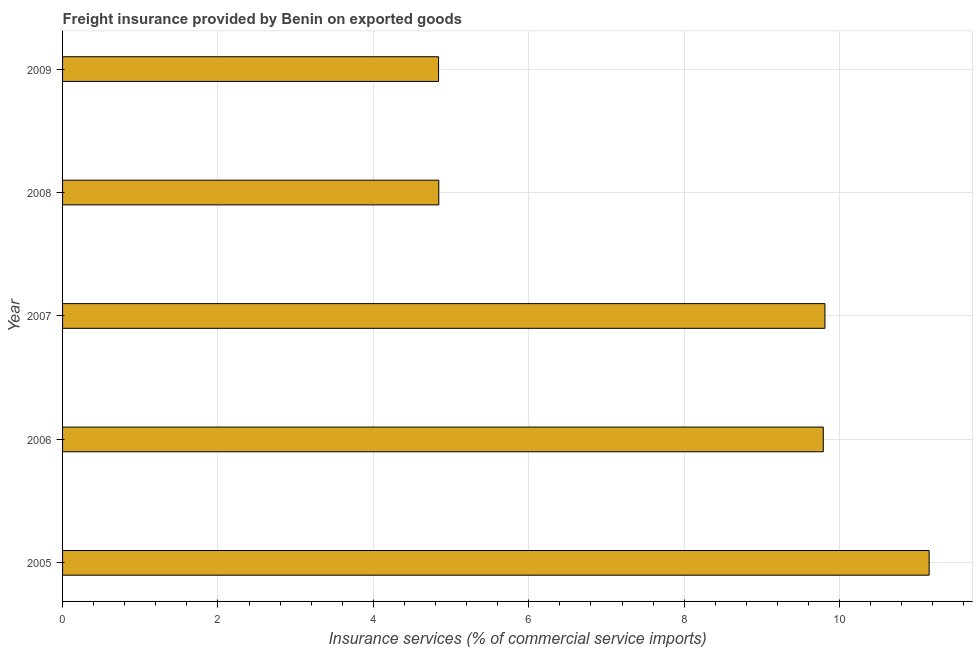Does the graph contain grids?
Your response must be concise. Yes. What is the title of the graph?
Give a very brief answer. Freight insurance provided by Benin on exported goods . What is the label or title of the X-axis?
Your response must be concise. Insurance services (% of commercial service imports). What is the freight insurance in 2009?
Ensure brevity in your answer.  4.84. Across all years, what is the maximum freight insurance?
Give a very brief answer. 11.15. Across all years, what is the minimum freight insurance?
Your answer should be compact. 4.84. In which year was the freight insurance maximum?
Ensure brevity in your answer.  2005. In which year was the freight insurance minimum?
Give a very brief answer. 2009. What is the sum of the freight insurance?
Offer a terse response. 40.43. What is the difference between the freight insurance in 2006 and 2009?
Offer a terse response. 4.95. What is the average freight insurance per year?
Your answer should be compact. 8.09. What is the median freight insurance?
Your answer should be very brief. 9.79. Do a majority of the years between 2009 and 2005 (inclusive) have freight insurance greater than 10.8 %?
Offer a very short reply. Yes. What is the ratio of the freight insurance in 2008 to that in 2009?
Your answer should be compact. 1. Is the freight insurance in 2007 less than that in 2009?
Provide a succinct answer. No. Is the difference between the freight insurance in 2006 and 2009 greater than the difference between any two years?
Ensure brevity in your answer.  No. What is the difference between the highest and the second highest freight insurance?
Your answer should be compact. 1.34. Is the sum of the freight insurance in 2008 and 2009 greater than the maximum freight insurance across all years?
Make the answer very short. No. What is the difference between the highest and the lowest freight insurance?
Your answer should be compact. 6.31. In how many years, is the freight insurance greater than the average freight insurance taken over all years?
Offer a terse response. 3. How many bars are there?
Make the answer very short. 5. How many years are there in the graph?
Give a very brief answer. 5. What is the difference between two consecutive major ticks on the X-axis?
Offer a very short reply. 2. Are the values on the major ticks of X-axis written in scientific E-notation?
Ensure brevity in your answer.  No. What is the Insurance services (% of commercial service imports) of 2005?
Provide a succinct answer. 11.15. What is the Insurance services (% of commercial service imports) of 2006?
Ensure brevity in your answer.  9.79. What is the Insurance services (% of commercial service imports) of 2007?
Offer a very short reply. 9.81. What is the Insurance services (% of commercial service imports) in 2008?
Provide a short and direct response. 4.84. What is the Insurance services (% of commercial service imports) of 2009?
Offer a terse response. 4.84. What is the difference between the Insurance services (% of commercial service imports) in 2005 and 2006?
Offer a terse response. 1.36. What is the difference between the Insurance services (% of commercial service imports) in 2005 and 2007?
Your response must be concise. 1.34. What is the difference between the Insurance services (% of commercial service imports) in 2005 and 2008?
Keep it short and to the point. 6.31. What is the difference between the Insurance services (% of commercial service imports) in 2005 and 2009?
Provide a short and direct response. 6.31. What is the difference between the Insurance services (% of commercial service imports) in 2006 and 2007?
Your response must be concise. -0.02. What is the difference between the Insurance services (% of commercial service imports) in 2006 and 2008?
Give a very brief answer. 4.95. What is the difference between the Insurance services (% of commercial service imports) in 2006 and 2009?
Ensure brevity in your answer.  4.95. What is the difference between the Insurance services (% of commercial service imports) in 2007 and 2008?
Your answer should be very brief. 4.97. What is the difference between the Insurance services (% of commercial service imports) in 2007 and 2009?
Ensure brevity in your answer.  4.97. What is the difference between the Insurance services (% of commercial service imports) in 2008 and 2009?
Your answer should be compact. 0. What is the ratio of the Insurance services (% of commercial service imports) in 2005 to that in 2006?
Offer a very short reply. 1.14. What is the ratio of the Insurance services (% of commercial service imports) in 2005 to that in 2007?
Give a very brief answer. 1.14. What is the ratio of the Insurance services (% of commercial service imports) in 2005 to that in 2008?
Make the answer very short. 2.3. What is the ratio of the Insurance services (% of commercial service imports) in 2005 to that in 2009?
Ensure brevity in your answer.  2.31. What is the ratio of the Insurance services (% of commercial service imports) in 2006 to that in 2008?
Your answer should be compact. 2.02. What is the ratio of the Insurance services (% of commercial service imports) in 2006 to that in 2009?
Make the answer very short. 2.02. What is the ratio of the Insurance services (% of commercial service imports) in 2007 to that in 2008?
Provide a succinct answer. 2.03. What is the ratio of the Insurance services (% of commercial service imports) in 2007 to that in 2009?
Offer a very short reply. 2.03. 